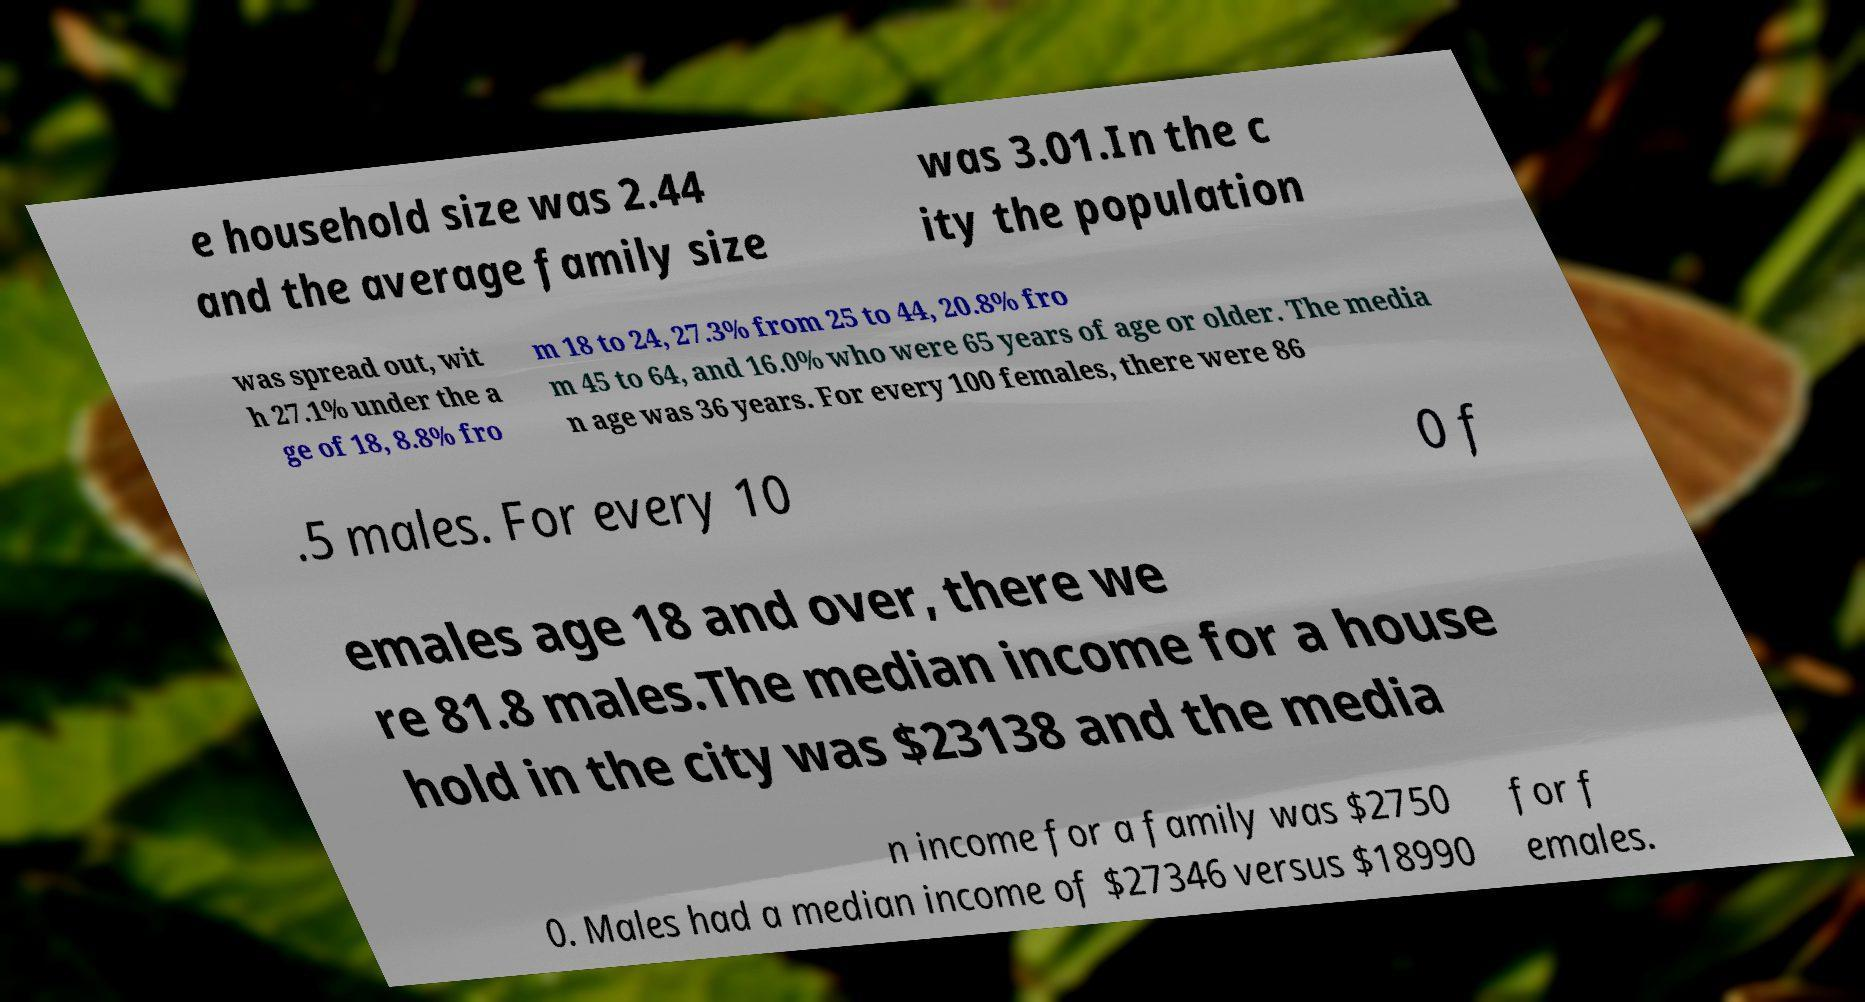Could you assist in decoding the text presented in this image and type it out clearly? e household size was 2.44 and the average family size was 3.01.In the c ity the population was spread out, wit h 27.1% under the a ge of 18, 8.8% fro m 18 to 24, 27.3% from 25 to 44, 20.8% fro m 45 to 64, and 16.0% who were 65 years of age or older. The media n age was 36 years. For every 100 females, there were 86 .5 males. For every 10 0 f emales age 18 and over, there we re 81.8 males.The median income for a house hold in the city was $23138 and the media n income for a family was $2750 0. Males had a median income of $27346 versus $18990 for f emales. 